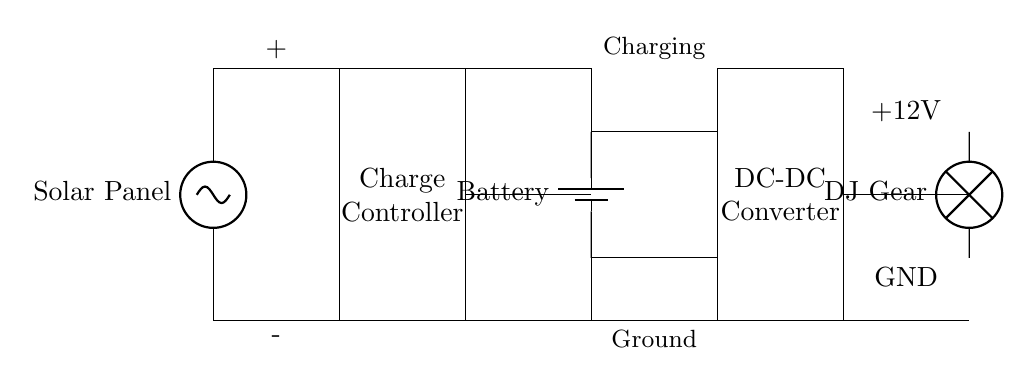What is the main power source in this circuit? The circuit uses a solar panel as its main source of power, as indicated at the top of the diagram with the label "Solar Panel."
Answer: Solar Panel What components are present in this circuit? The circuit includes a solar panel, charge controller, battery, DC-DC converter, and DJ gear as its load. These components can be directly identified from the labels in the diagram.
Answer: Solar Panel, Charge Controller, Battery, DC-DC Converter, DJ Gear What voltage does the DJ gear require? The diagram labels the output voltage for the DJ gear as +12V, which indicates the required voltage level for operation.
Answer: +12V Which component regulates the current before it reaches the battery? The charge controller is specifically designed to regulate the voltage and current flowing to the battery from the solar panel, as indicated by its placement in the circuit.
Answer: Charge Controller How does the electricity flow from the solar panel to the DJ gear? The flow of electricity starts from the solar panel, goes through the charge controller, charges the battery, passes through the DC-DC converter, and finally reaches the DJ gear. This is deduced from the connection lines shown in the diagram.
Answer: Solar Panel → Charge Controller → Battery → DC-DC Converter → DJ Gear What is the purpose of the DC-DC converter in this circuit? The DC-DC converter steps down or regulates the voltage coming from the battery to the appropriate level (+12V) needed for the DJ equipment, ensuring it receives the correct voltage.
Answer: Regulate voltage What happens if the solar panel is not generating enough power? If the solar panel does not generate sufficient power, the battery will not be charged adequately, leading to insufficient power supply to the DJ gear. This is inferred from the dependency of the load on both the charge controller and battery.
Answer: Insufficient power supply 